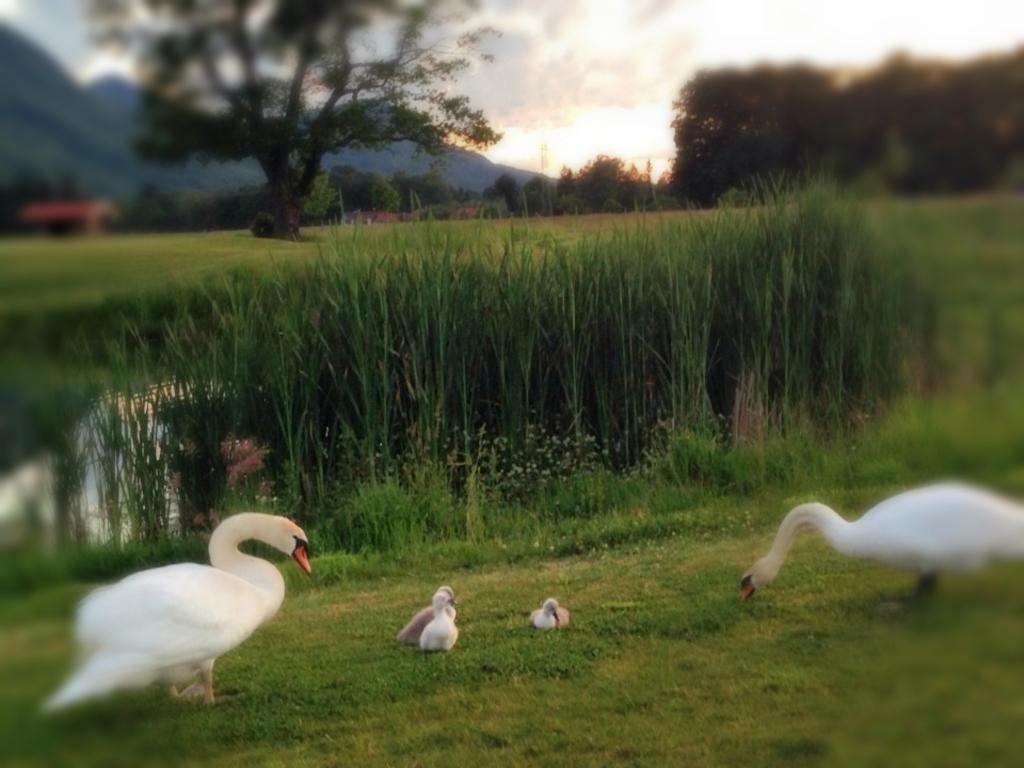How would you summarize this image in a sentence or two? In this image we can see ducks and ducklings on the ground, trees, building, hills and sky with clouds. 